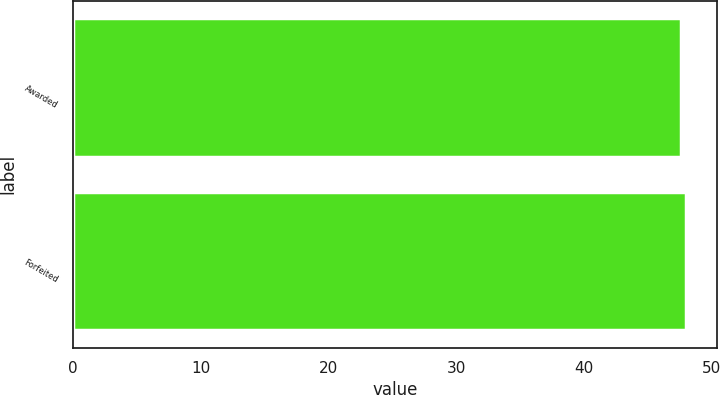<chart> <loc_0><loc_0><loc_500><loc_500><bar_chart><fcel>Awarded<fcel>Forfeited<nl><fcel>47.56<fcel>48.01<nl></chart> 